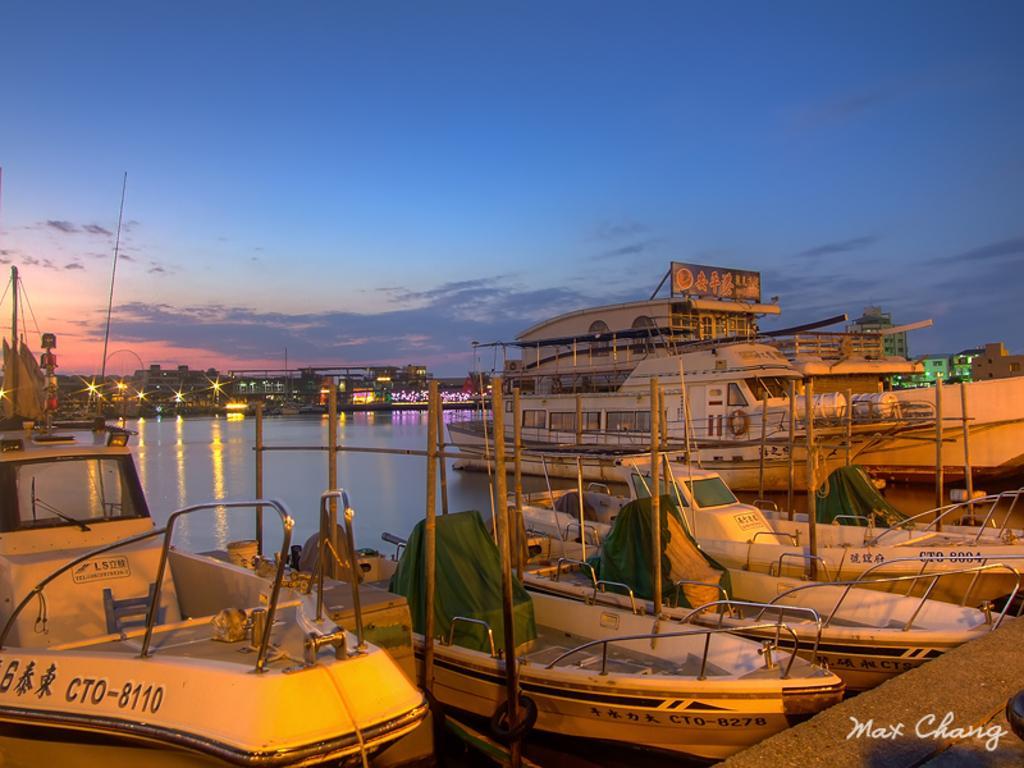In one or two sentences, can you explain what this image depicts? This image consists of boats and ships. On the right, we can see a floor. In the middle, there is water. In the background, there are lights and houses. The boats are in white color. 